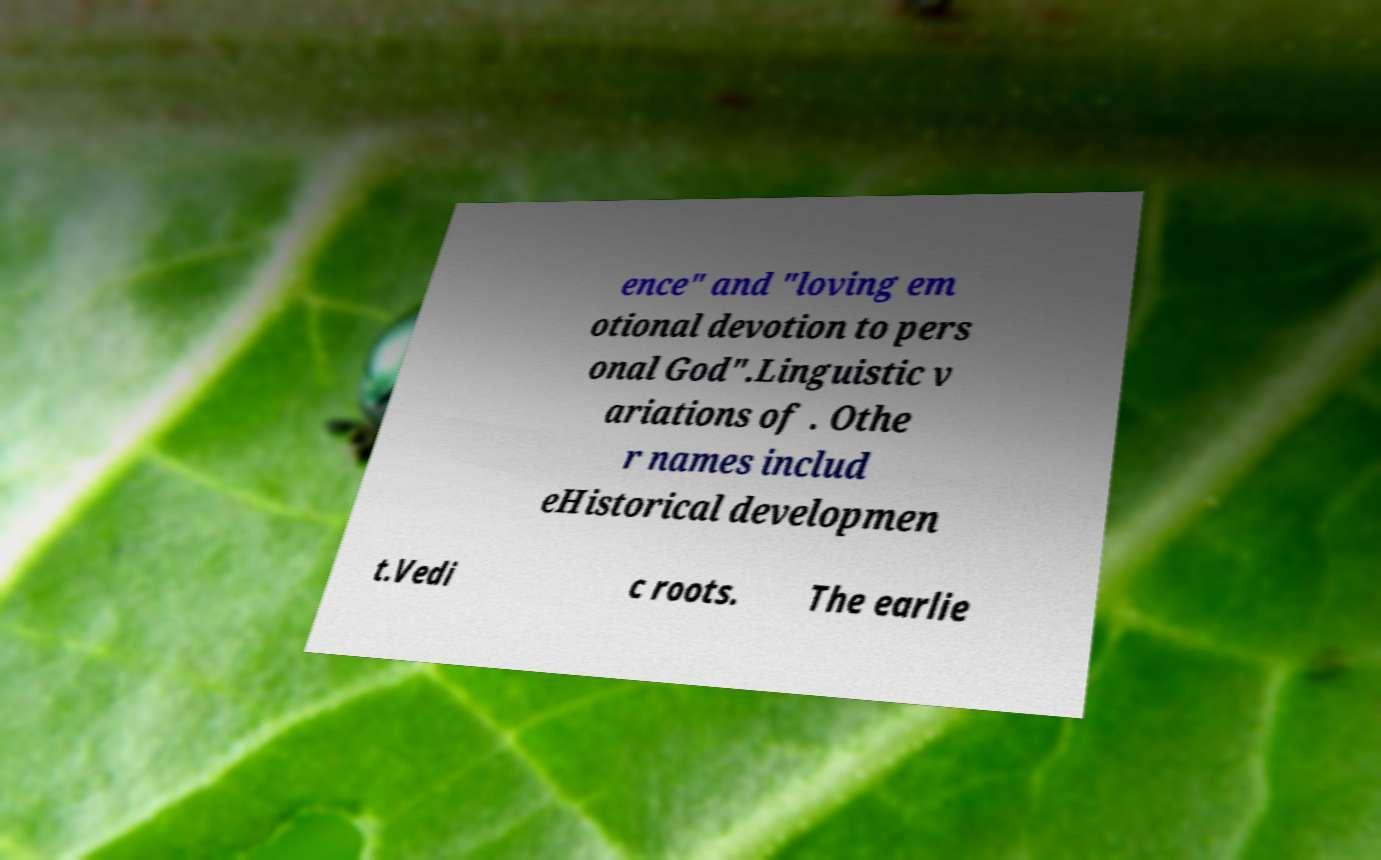Could you assist in decoding the text presented in this image and type it out clearly? ence" and "loving em otional devotion to pers onal God".Linguistic v ariations of . Othe r names includ eHistorical developmen t.Vedi c roots. The earlie 